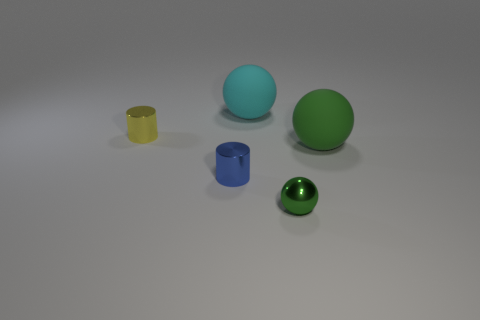Subtract all small green metal spheres. How many spheres are left? 2 Add 5 large brown matte cylinders. How many objects exist? 10 Subtract 1 cylinders. How many cylinders are left? 1 Subtract all cyan spheres. How many spheres are left? 2 Subtract all gray cylinders. How many green spheres are left? 2 Subtract all large green cylinders. Subtract all small green metallic things. How many objects are left? 4 Add 3 tiny things. How many tiny things are left? 6 Add 4 small brown metallic cylinders. How many small brown metallic cylinders exist? 4 Subtract 0 red balls. How many objects are left? 5 Subtract all spheres. How many objects are left? 2 